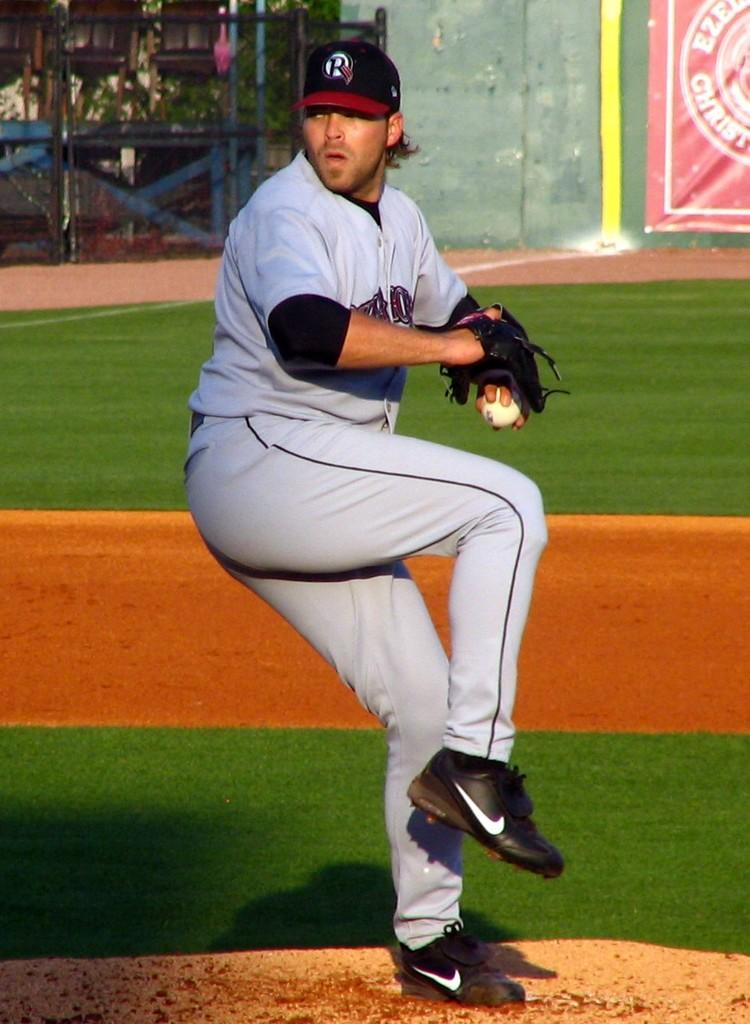<image>
Share a concise interpretation of the image provided. a baseball player wearing a hat with an r icon on it 